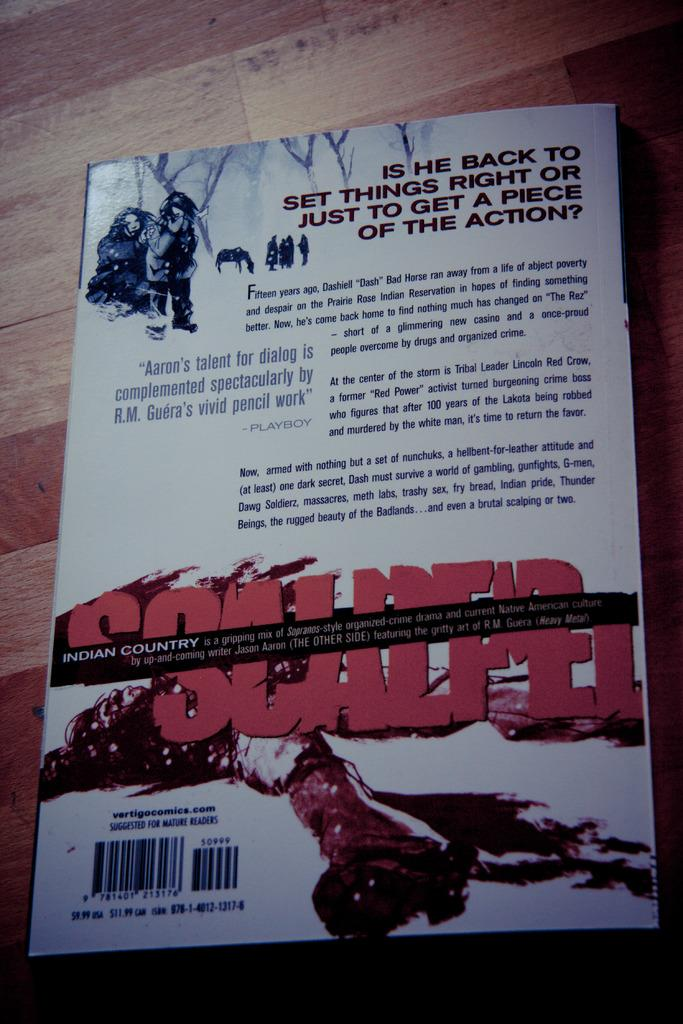<image>
Relay a brief, clear account of the picture shown. Book about the Indian country  who is all about  casino and crime 